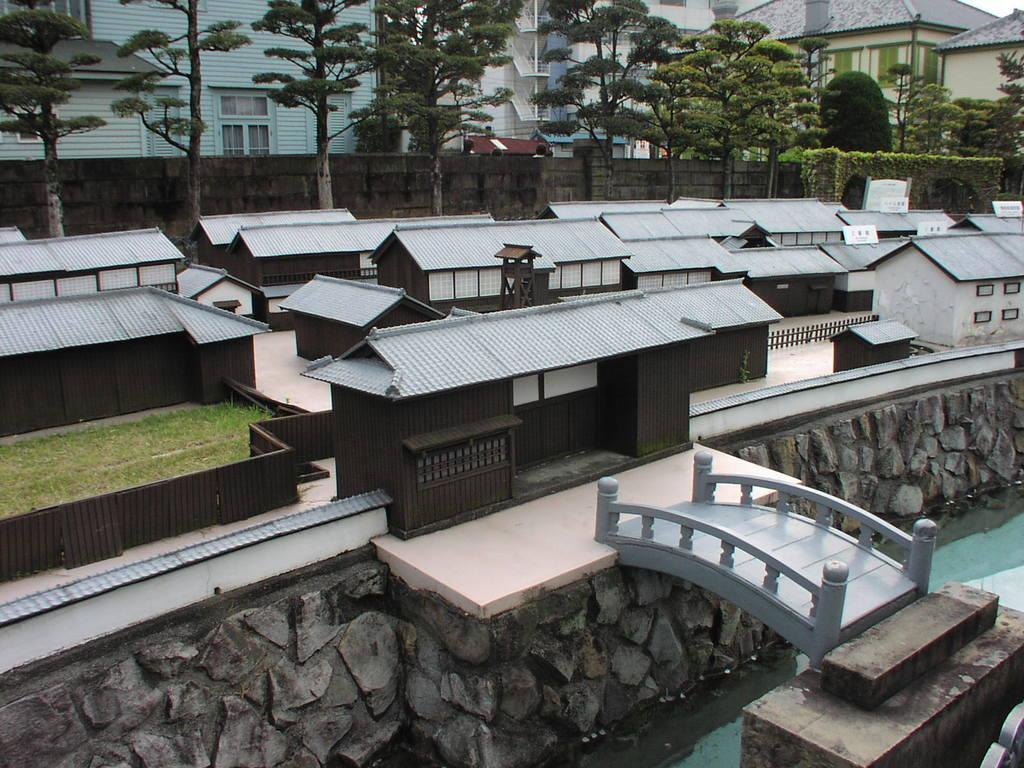In one or two sentences, can you explain what this image depicts? In this picture I can see few miniatures and I can see trees and few buildings. 